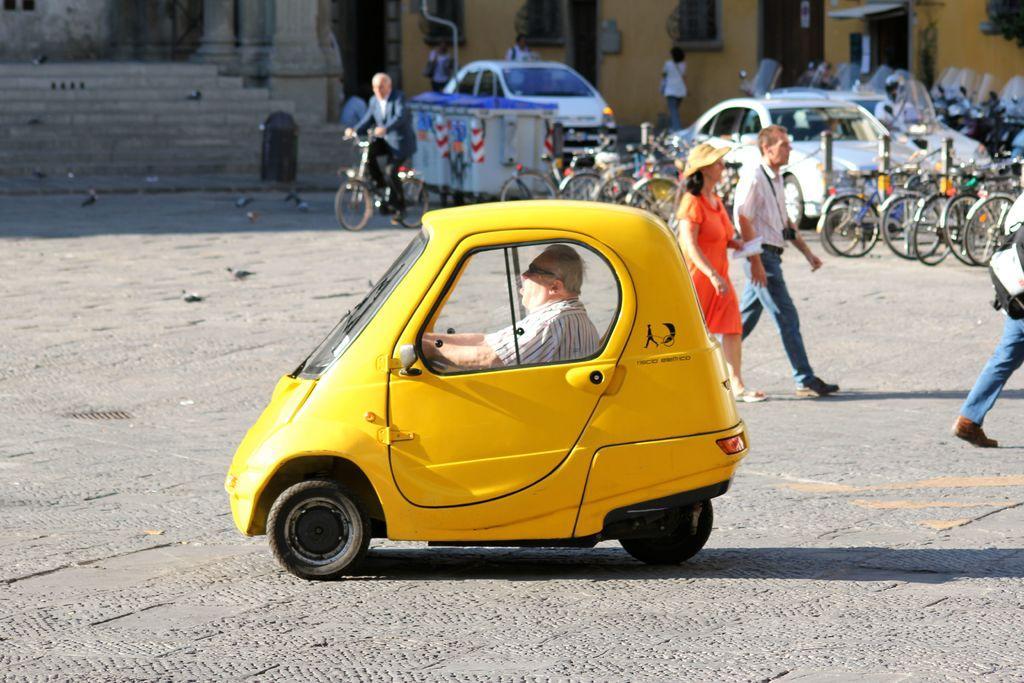In one or two sentences, can you explain what this image depicts? In the picture we can see a people walking on the road and one person sitting in a car, car is yellow in colour, and one man is riding a bicycle, in the background we can see many cycles, cars, building, and steps and some birds. 